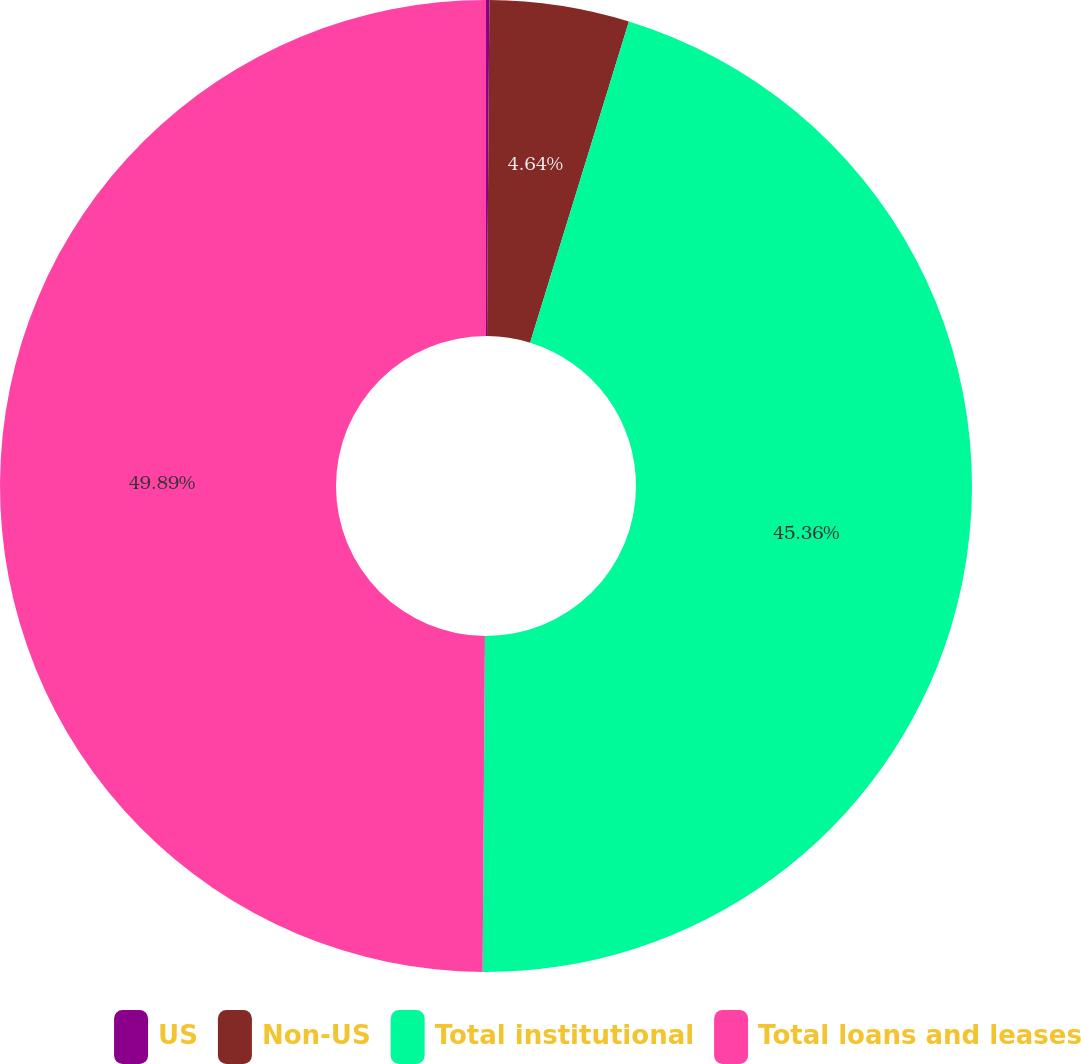Convert chart to OTSL. <chart><loc_0><loc_0><loc_500><loc_500><pie_chart><fcel>US<fcel>Non-US<fcel>Total institutional<fcel>Total loans and leases<nl><fcel>0.11%<fcel>4.64%<fcel>45.36%<fcel>49.89%<nl></chart> 